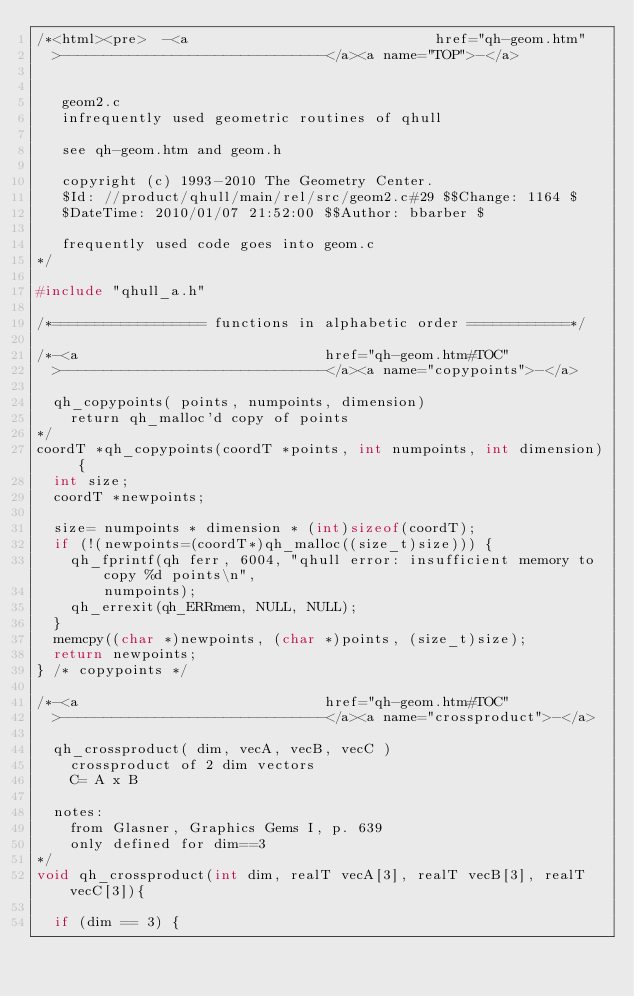<code> <loc_0><loc_0><loc_500><loc_500><_C_>/*<html><pre>  -<a                             href="qh-geom.htm"
  >-------------------------------</a><a name="TOP">-</a>


   geom2.c
   infrequently used geometric routines of qhull

   see qh-geom.htm and geom.h

   copyright (c) 1993-2010 The Geometry Center.
   $Id: //product/qhull/main/rel/src/geom2.c#29 $$Change: 1164 $
   $DateTime: 2010/01/07 21:52:00 $$Author: bbarber $

   frequently used code goes into geom.c
*/

#include "qhull_a.h"

/*================== functions in alphabetic order ============*/

/*-<a                             href="qh-geom.htm#TOC"
  >-------------------------------</a><a name="copypoints">-</a>

  qh_copypoints( points, numpoints, dimension)
    return qh_malloc'd copy of points
*/
coordT *qh_copypoints(coordT *points, int numpoints, int dimension) {
  int size;
  coordT *newpoints;

  size= numpoints * dimension * (int)sizeof(coordT);
  if (!(newpoints=(coordT*)qh_malloc((size_t)size))) {
    qh_fprintf(qh ferr, 6004, "qhull error: insufficient memory to copy %d points\n",
        numpoints);
    qh_errexit(qh_ERRmem, NULL, NULL);
  }
  memcpy((char *)newpoints, (char *)points, (size_t)size);
  return newpoints;
} /* copypoints */

/*-<a                             href="qh-geom.htm#TOC"
  >-------------------------------</a><a name="crossproduct">-</a>

  qh_crossproduct( dim, vecA, vecB, vecC )
    crossproduct of 2 dim vectors
    C= A x B

  notes:
    from Glasner, Graphics Gems I, p. 639
    only defined for dim==3
*/
void qh_crossproduct(int dim, realT vecA[3], realT vecB[3], realT vecC[3]){

  if (dim == 3) {</code> 